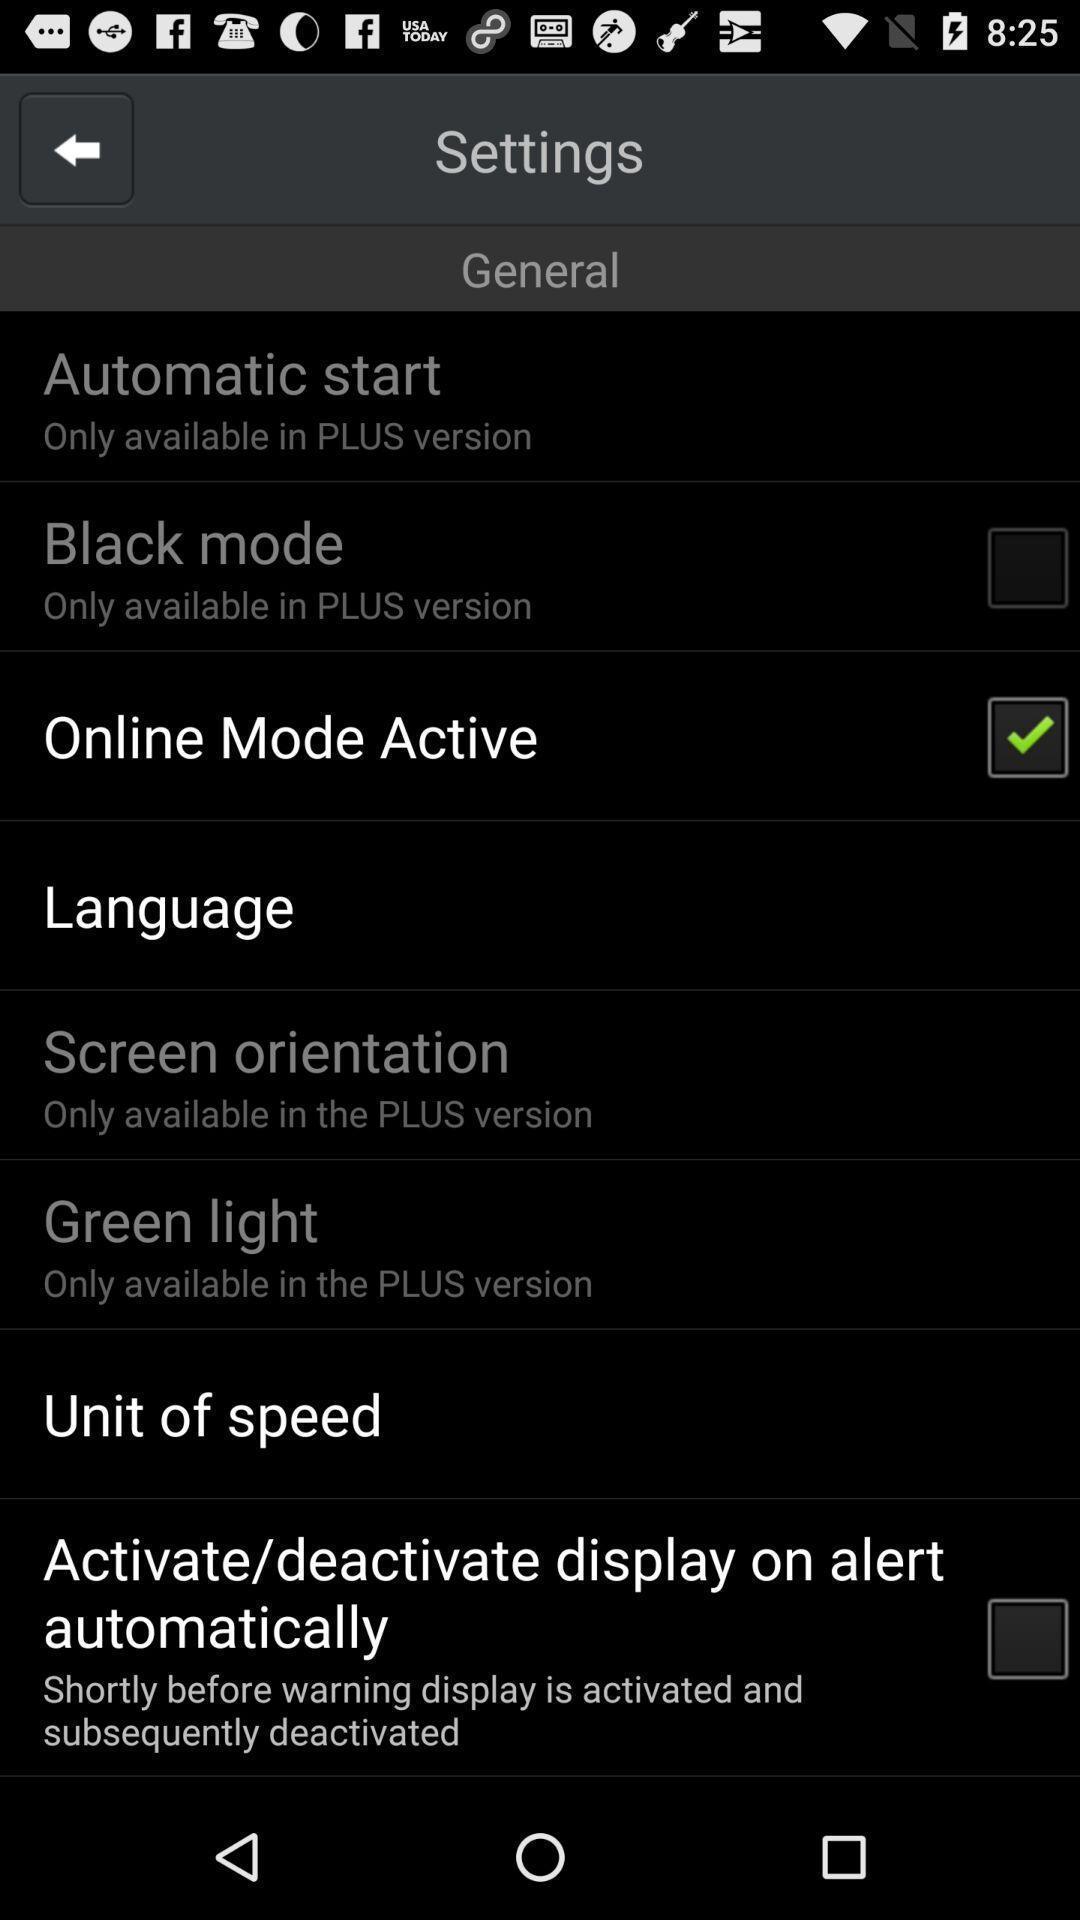What is the overall content of this screenshot? Settings page with multiple options. 